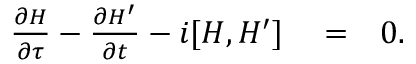Convert formula to latex. <formula><loc_0><loc_0><loc_500><loc_500>\begin{array} { r l r } { \frac { \partial H } { \partial \tau } - \frac { \partial H ^ { \prime } } { \partial t } - i [ H , H ^ { \prime } ] } & = } & { 0 . } \end{array}</formula> 